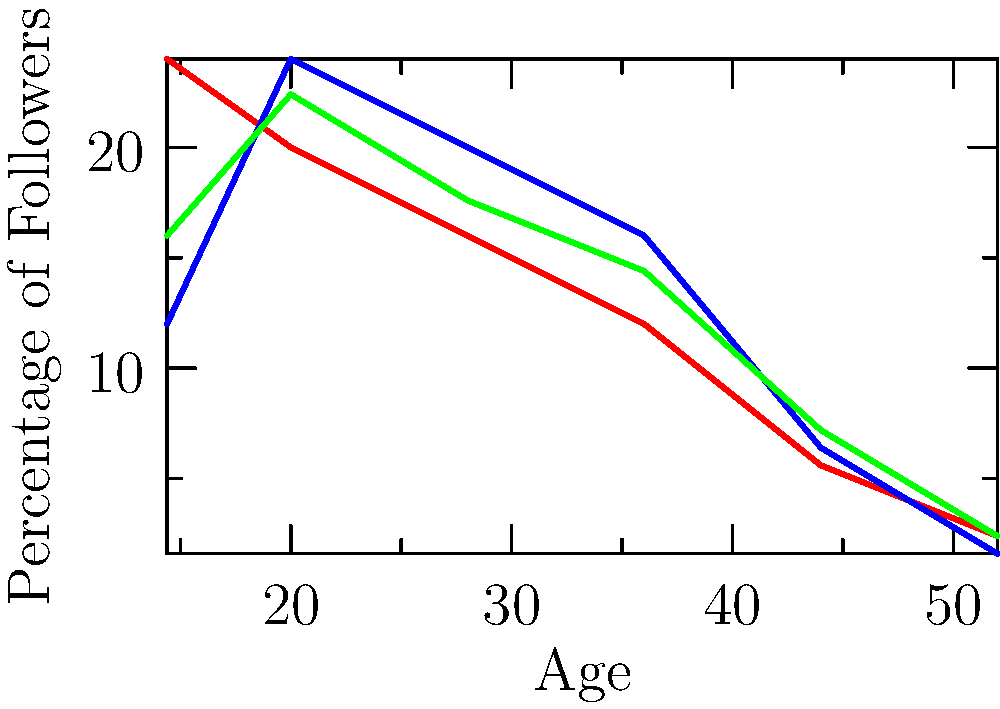Based on the graph showing the age demographics of followers for three rising political figures in Brazil, which politician has the highest percentage of followers in the 25-35 age range? To determine which politician has the highest percentage of followers in the 25-35 age range, we need to analyze the graph for each politician at the 25 and 35 age points:

1. Politician A (red line):
   At age 25: approximately 25%
   At age 35: approximately 20%
   Average in the 25-35 range: (25% + 20%) / 2 = 22.5%

2. Politician B (blue line):
   At age 25: approximately 30%
   At age 35: approximately 25%
   Average in the 25-35 range: (30% + 25%) / 2 = 27.5%

3. Politician C (green line):
   At age 25: approximately 28%
   At age 35: approximately 22%
   Average in the 25-35 range: (28% + 22%) / 2 = 25%

Comparing these averages, we can see that Politician B has the highest percentage of followers in the 25-35 age range.
Answer: Politician B 